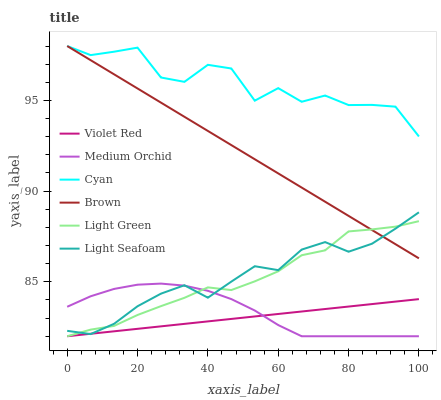Does Violet Red have the minimum area under the curve?
Answer yes or no. Yes. Does Cyan have the maximum area under the curve?
Answer yes or no. Yes. Does Medium Orchid have the minimum area under the curve?
Answer yes or no. No. Does Medium Orchid have the maximum area under the curve?
Answer yes or no. No. Is Violet Red the smoothest?
Answer yes or no. Yes. Is Cyan the roughest?
Answer yes or no. Yes. Is Medium Orchid the smoothest?
Answer yes or no. No. Is Medium Orchid the roughest?
Answer yes or no. No. Does Violet Red have the lowest value?
Answer yes or no. Yes. Does Cyan have the lowest value?
Answer yes or no. No. Does Cyan have the highest value?
Answer yes or no. Yes. Does Medium Orchid have the highest value?
Answer yes or no. No. Is Violet Red less than Cyan?
Answer yes or no. Yes. Is Brown greater than Medium Orchid?
Answer yes or no. Yes. Does Medium Orchid intersect Violet Red?
Answer yes or no. Yes. Is Medium Orchid less than Violet Red?
Answer yes or no. No. Is Medium Orchid greater than Violet Red?
Answer yes or no. No. Does Violet Red intersect Cyan?
Answer yes or no. No. 